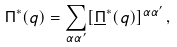<formula> <loc_0><loc_0><loc_500><loc_500>\Pi ^ { \ast } ( q ) = \sum _ { \alpha \alpha ^ { \prime } } [ \underline { \Pi } ^ { \ast } ( q ) ] ^ { \alpha \alpha ^ { \prime } } \, ,</formula> 